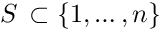Convert formula to latex. <formula><loc_0><loc_0><loc_500><loc_500>S \, \subset \{ 1 , \dots , n \}</formula> 